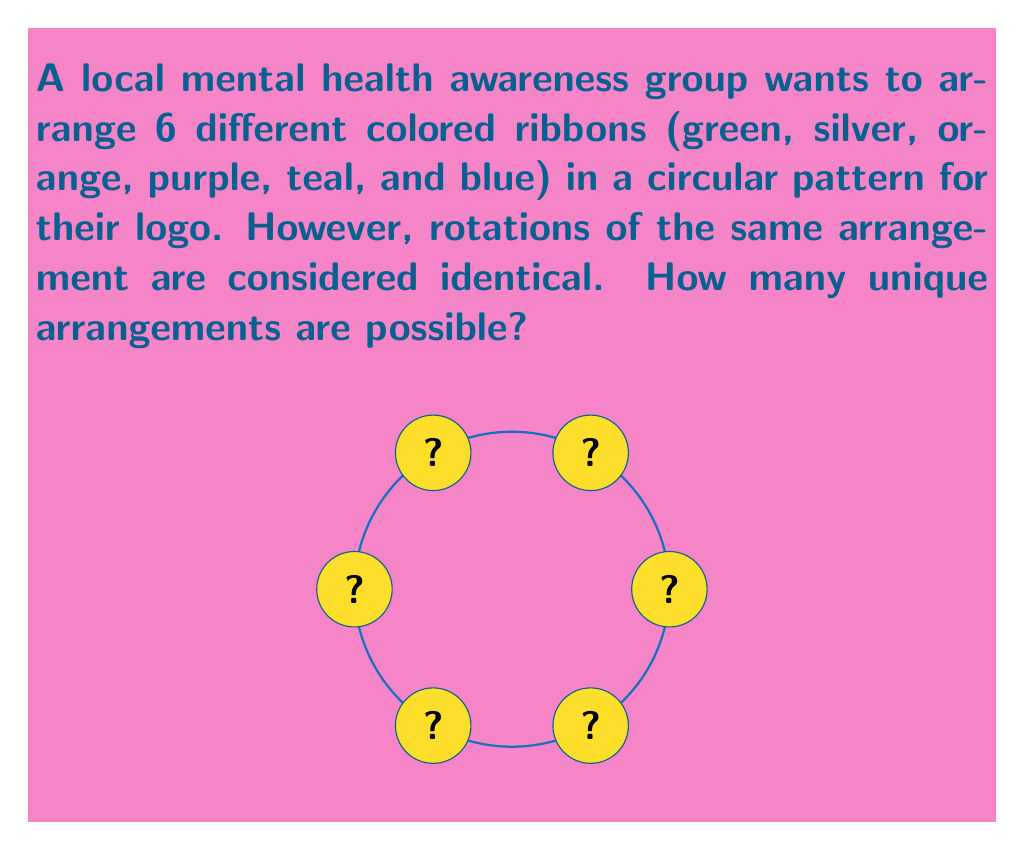Give your solution to this math problem. Let's approach this step-by-step:

1) First, we need to recognize that this is a problem involving cyclic permutations. In a cyclic permutation, rotations of the same arrangement are considered identical.

2) For n distinct objects, the number of cyclic permutations is given by the formula:

   $$(n-1)!$$

3) In this case, we have 6 distinct colored ribbons, so n = 6.

4) Applying the formula:

   $$(6-1)! = 5!$$

5) Calculate 5!:

   $$5! = 5 \times 4 \times 3 \times 2 \times 1 = 120$$

6) Therefore, there are 120 unique arrangements of the 6 colored ribbons in a circular pattern.

This problem relates to permutation groups in abstract algebra. The cyclic group $C_6$ acts on the set of all 6! permutations, and the number of unique arrangements is the number of orbits under this group action, which is given by the formula we used.
Answer: 120 